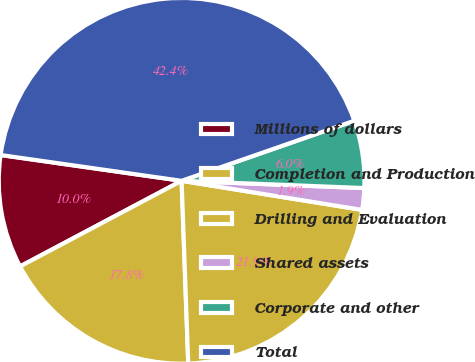Convert chart to OTSL. <chart><loc_0><loc_0><loc_500><loc_500><pie_chart><fcel>Millions of dollars<fcel>Completion and Production<fcel>Drilling and Evaluation<fcel>Shared assets<fcel>Corporate and other<fcel>Total<nl><fcel>10.01%<fcel>17.82%<fcel>21.88%<fcel>1.91%<fcel>5.96%<fcel>42.42%<nl></chart> 